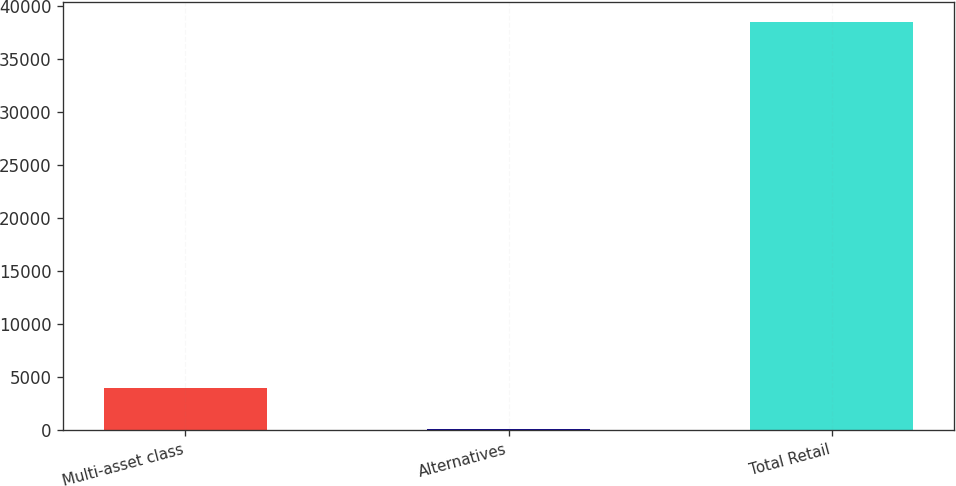<chart> <loc_0><loc_0><loc_500><loc_500><bar_chart><fcel>Multi-asset class<fcel>Alternatives<fcel>Total Retail<nl><fcel>3997<fcel>162<fcel>38512<nl></chart> 